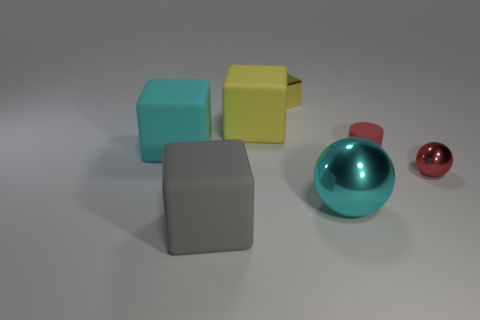Is the number of large objects that are in front of the red matte cylinder greater than the number of small metallic things that are behind the shiny cube?
Provide a succinct answer. Yes. What material is the big thing behind the cyan object left of the cyan metal sphere left of the red rubber thing?
Your answer should be compact. Rubber. There is a matte thing that is in front of the cylinder; is its shape the same as the cyan rubber thing left of the small red matte object?
Your answer should be compact. Yes. Is there a cyan sphere that has the same size as the red matte thing?
Provide a succinct answer. No. How many gray objects are small matte spheres or big things?
Keep it short and to the point. 1. What number of small rubber cylinders are the same color as the tiny shiny ball?
Offer a very short reply. 1. Are there any other things that are the same shape as the tiny red rubber object?
Make the answer very short. No. What number of balls are either big purple metallic objects or rubber objects?
Provide a short and direct response. 0. What is the color of the small object behind the small matte thing?
Keep it short and to the point. Yellow. What shape is the yellow metal thing that is the same size as the red metal thing?
Your answer should be compact. Cube. 